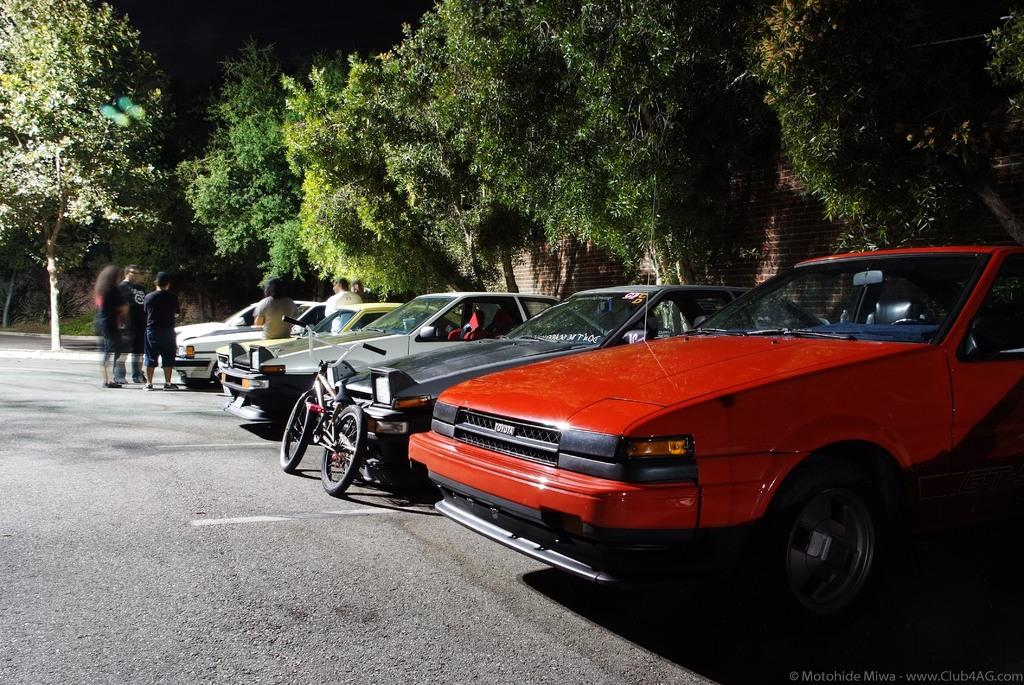What types of vehicles are present in the image? There are cars in the image. Are there any other modes of transportation visible? Yes, there is a bicycle in the image. What can be seen in the background of the image? There are trees and a brick wall in the image. What is the presence of people on the road suggest? It suggests that there might be some activity or gathering happening on the road. What type of dock can be seen in the image? There is no dock present in the image. What kind of stew is being prepared by the people on the road? There is no stew being prepared in the image; the people are standing on the road. 